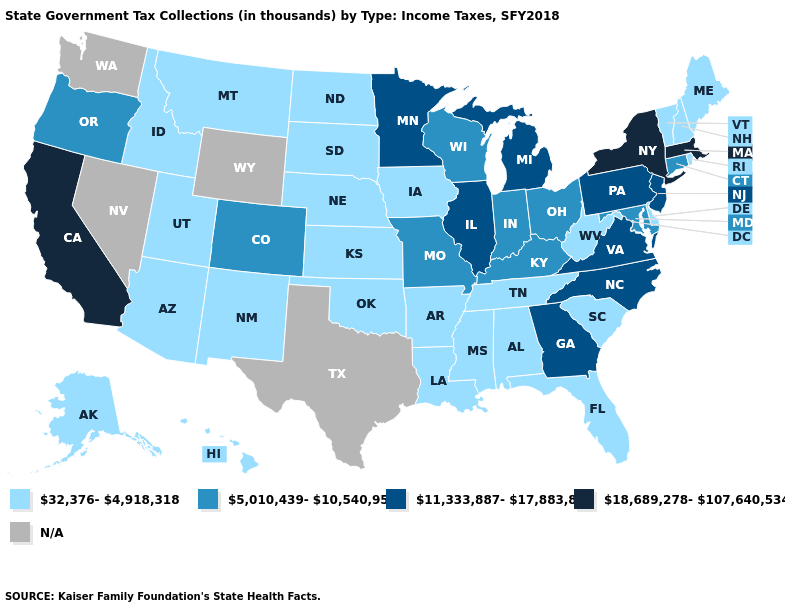What is the highest value in the MidWest ?
Be succinct. 11,333,887-17,883,834. Name the states that have a value in the range 11,333,887-17,883,834?
Quick response, please. Georgia, Illinois, Michigan, Minnesota, New Jersey, North Carolina, Pennsylvania, Virginia. What is the highest value in the South ?
Give a very brief answer. 11,333,887-17,883,834. What is the value of Oregon?
Answer briefly. 5,010,439-10,540,951. Name the states that have a value in the range 5,010,439-10,540,951?
Concise answer only. Colorado, Connecticut, Indiana, Kentucky, Maryland, Missouri, Ohio, Oregon, Wisconsin. What is the value of Idaho?
Answer briefly. 32,376-4,918,318. What is the highest value in the USA?
Answer briefly. 18,689,278-107,640,534. What is the value of Indiana?
Keep it brief. 5,010,439-10,540,951. Name the states that have a value in the range 5,010,439-10,540,951?
Short answer required. Colorado, Connecticut, Indiana, Kentucky, Maryland, Missouri, Ohio, Oregon, Wisconsin. What is the value of Georgia?
Answer briefly. 11,333,887-17,883,834. What is the lowest value in the USA?
Quick response, please. 32,376-4,918,318. Does California have the highest value in the West?
Be succinct. Yes. What is the highest value in the USA?
Be succinct. 18,689,278-107,640,534. Does Missouri have the highest value in the MidWest?
Concise answer only. No. 